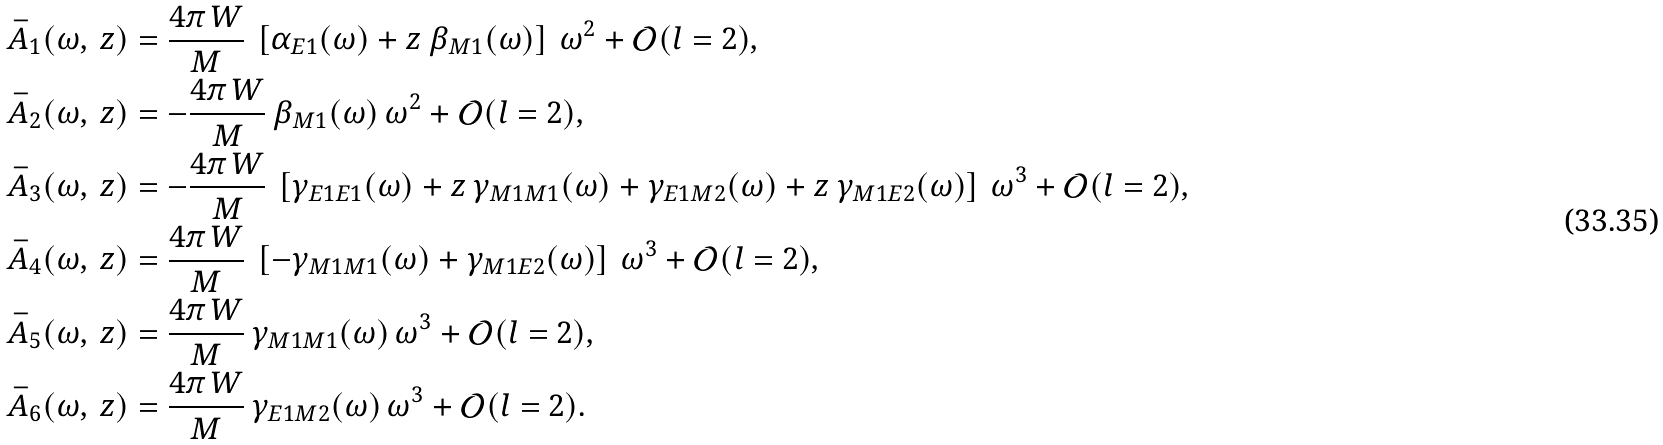Convert formula to latex. <formula><loc_0><loc_0><loc_500><loc_500>\bar { A } _ { 1 } ( \omega , \, z ) & = \frac { 4 \pi \, W } { M } \, \left [ \alpha _ { E 1 } ( \omega ) + z \, \beta _ { M 1 } ( \omega ) \right ] \, \omega ^ { 2 } + \mathcal { O } ( l = 2 ) , \\ \bar { A } _ { 2 } ( \omega , \, z ) & = - \frac { 4 \pi \, W } { M } \, \beta _ { M 1 } ( \omega ) \, \omega ^ { 2 } + \mathcal { O } ( l = 2 ) , \\ \bar { A } _ { 3 } ( \omega , \, z ) & = - \frac { 4 \pi \, W } { M } \, \left [ \gamma _ { E 1 E 1 } ( \omega ) + z \, \gamma _ { M 1 M 1 } ( \omega ) + \gamma _ { E 1 M 2 } ( \omega ) + z \, \gamma _ { M 1 E 2 } ( \omega ) \right ] \, \omega ^ { 3 } + \mathcal { O } ( l = 2 ) , \\ \bar { A } _ { 4 } ( \omega , \, z ) & = \frac { 4 \pi \, W } { M } \, \left [ - \gamma _ { M 1 M 1 } ( \omega ) + \gamma _ { M 1 E 2 } ( \omega ) \right ] \, \omega ^ { 3 } + \mathcal { O } ( l = 2 ) , \\ \bar { A } _ { 5 } ( \omega , \, z ) & = \frac { 4 \pi \, W } { M } \, \gamma _ { M 1 M 1 } ( \omega ) \, \omega ^ { 3 } + \mathcal { O } ( l = 2 ) , \\ \bar { A } _ { 6 } ( \omega , \, z ) & = \frac { 4 \pi \, W } { M } \, \gamma _ { E 1 M 2 } ( \omega ) \, \omega ^ { 3 } + \mathcal { O } ( l = 2 ) .</formula> 